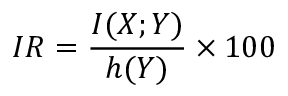Convert formula to latex. <formula><loc_0><loc_0><loc_500><loc_500>I R = \frac { I ( X ; Y ) } { h ( Y ) } \times 1 0 0 \</formula> 